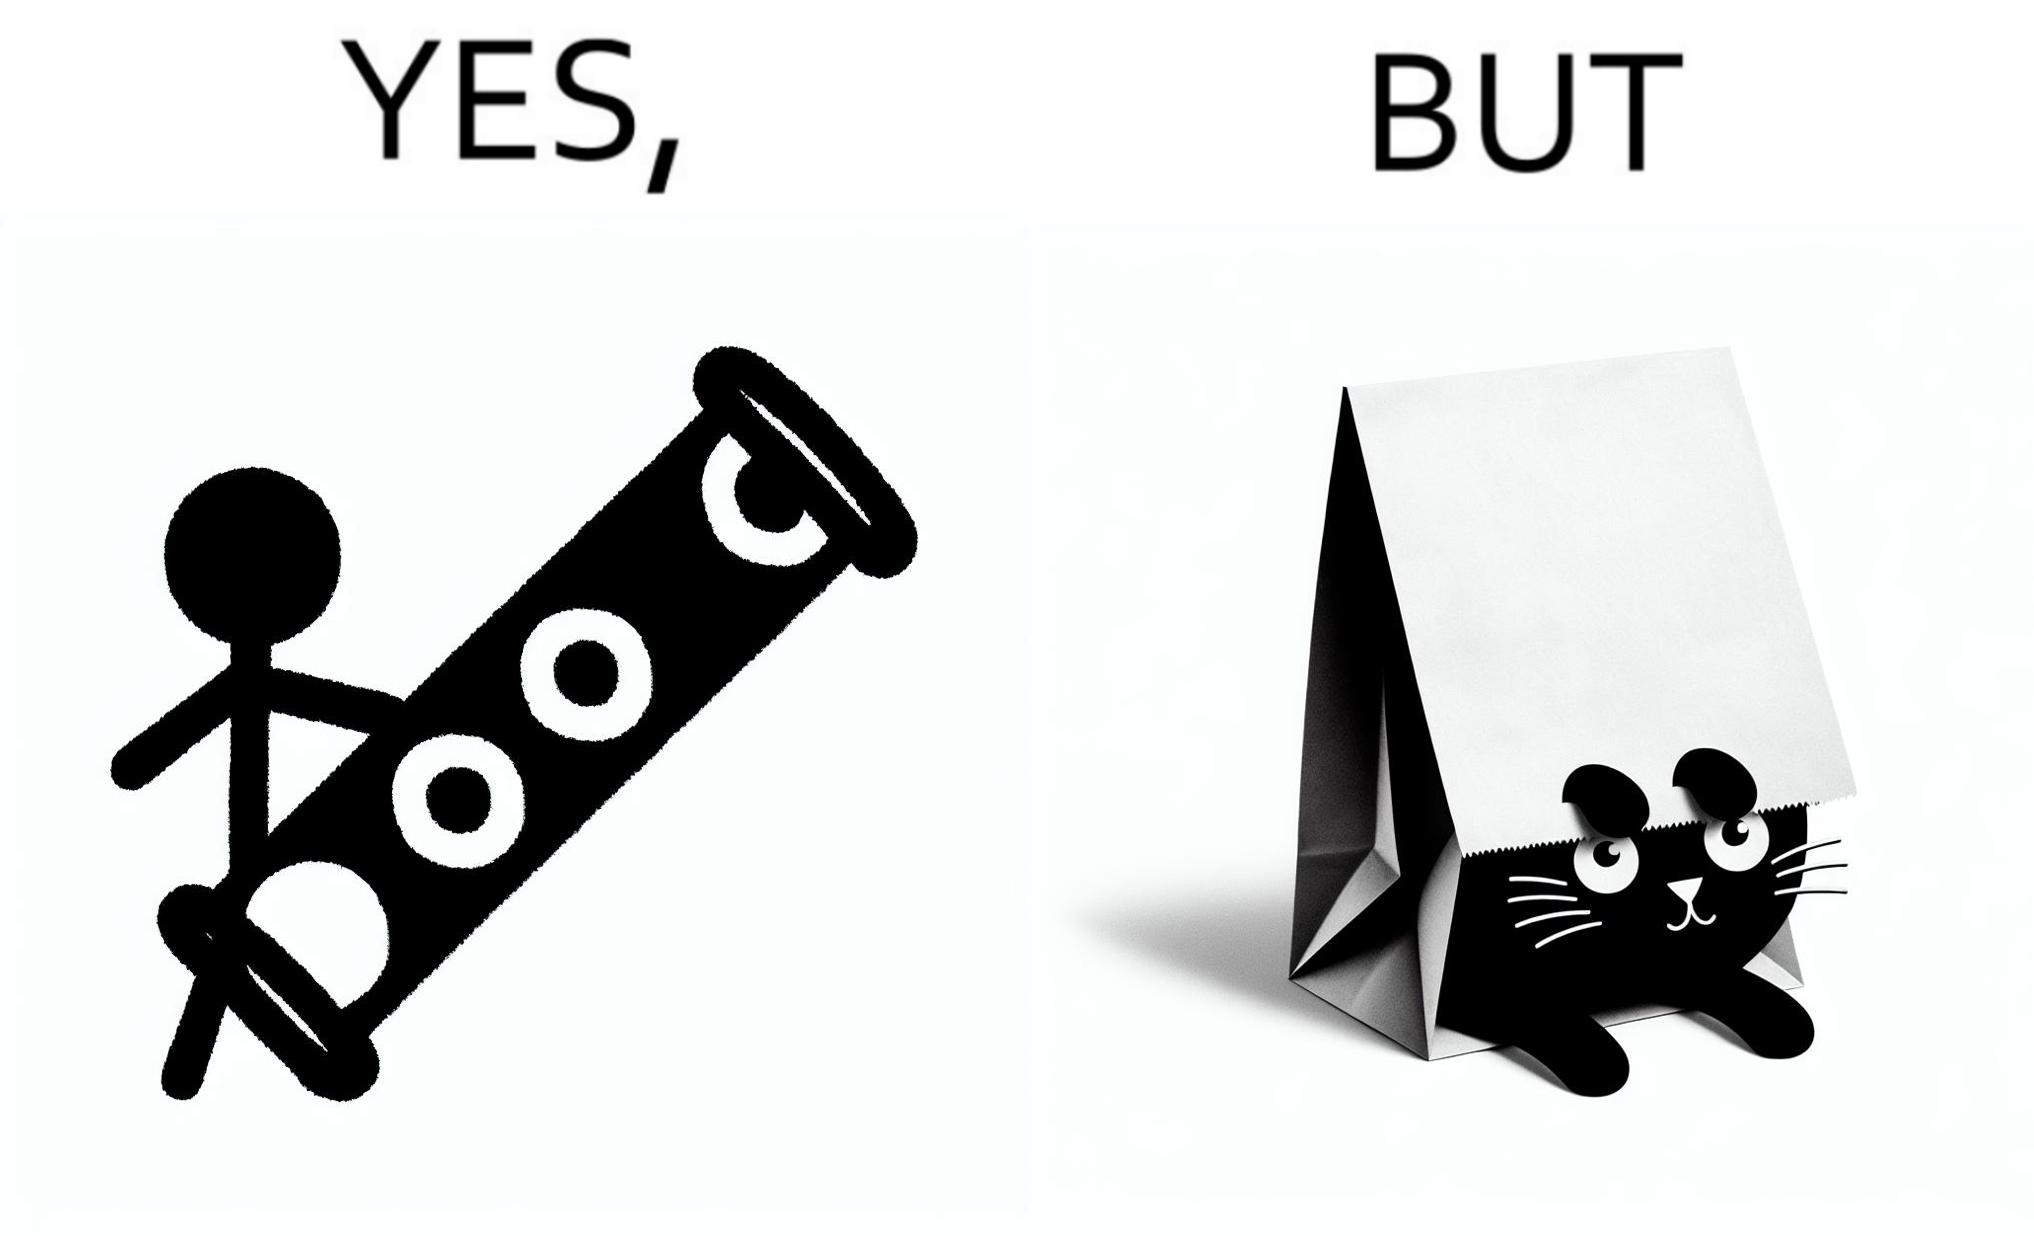What is shown in this image? The image is funny, because even when there is a dedicated thing for the animal to play with it still is hiding itself in the paper bag 